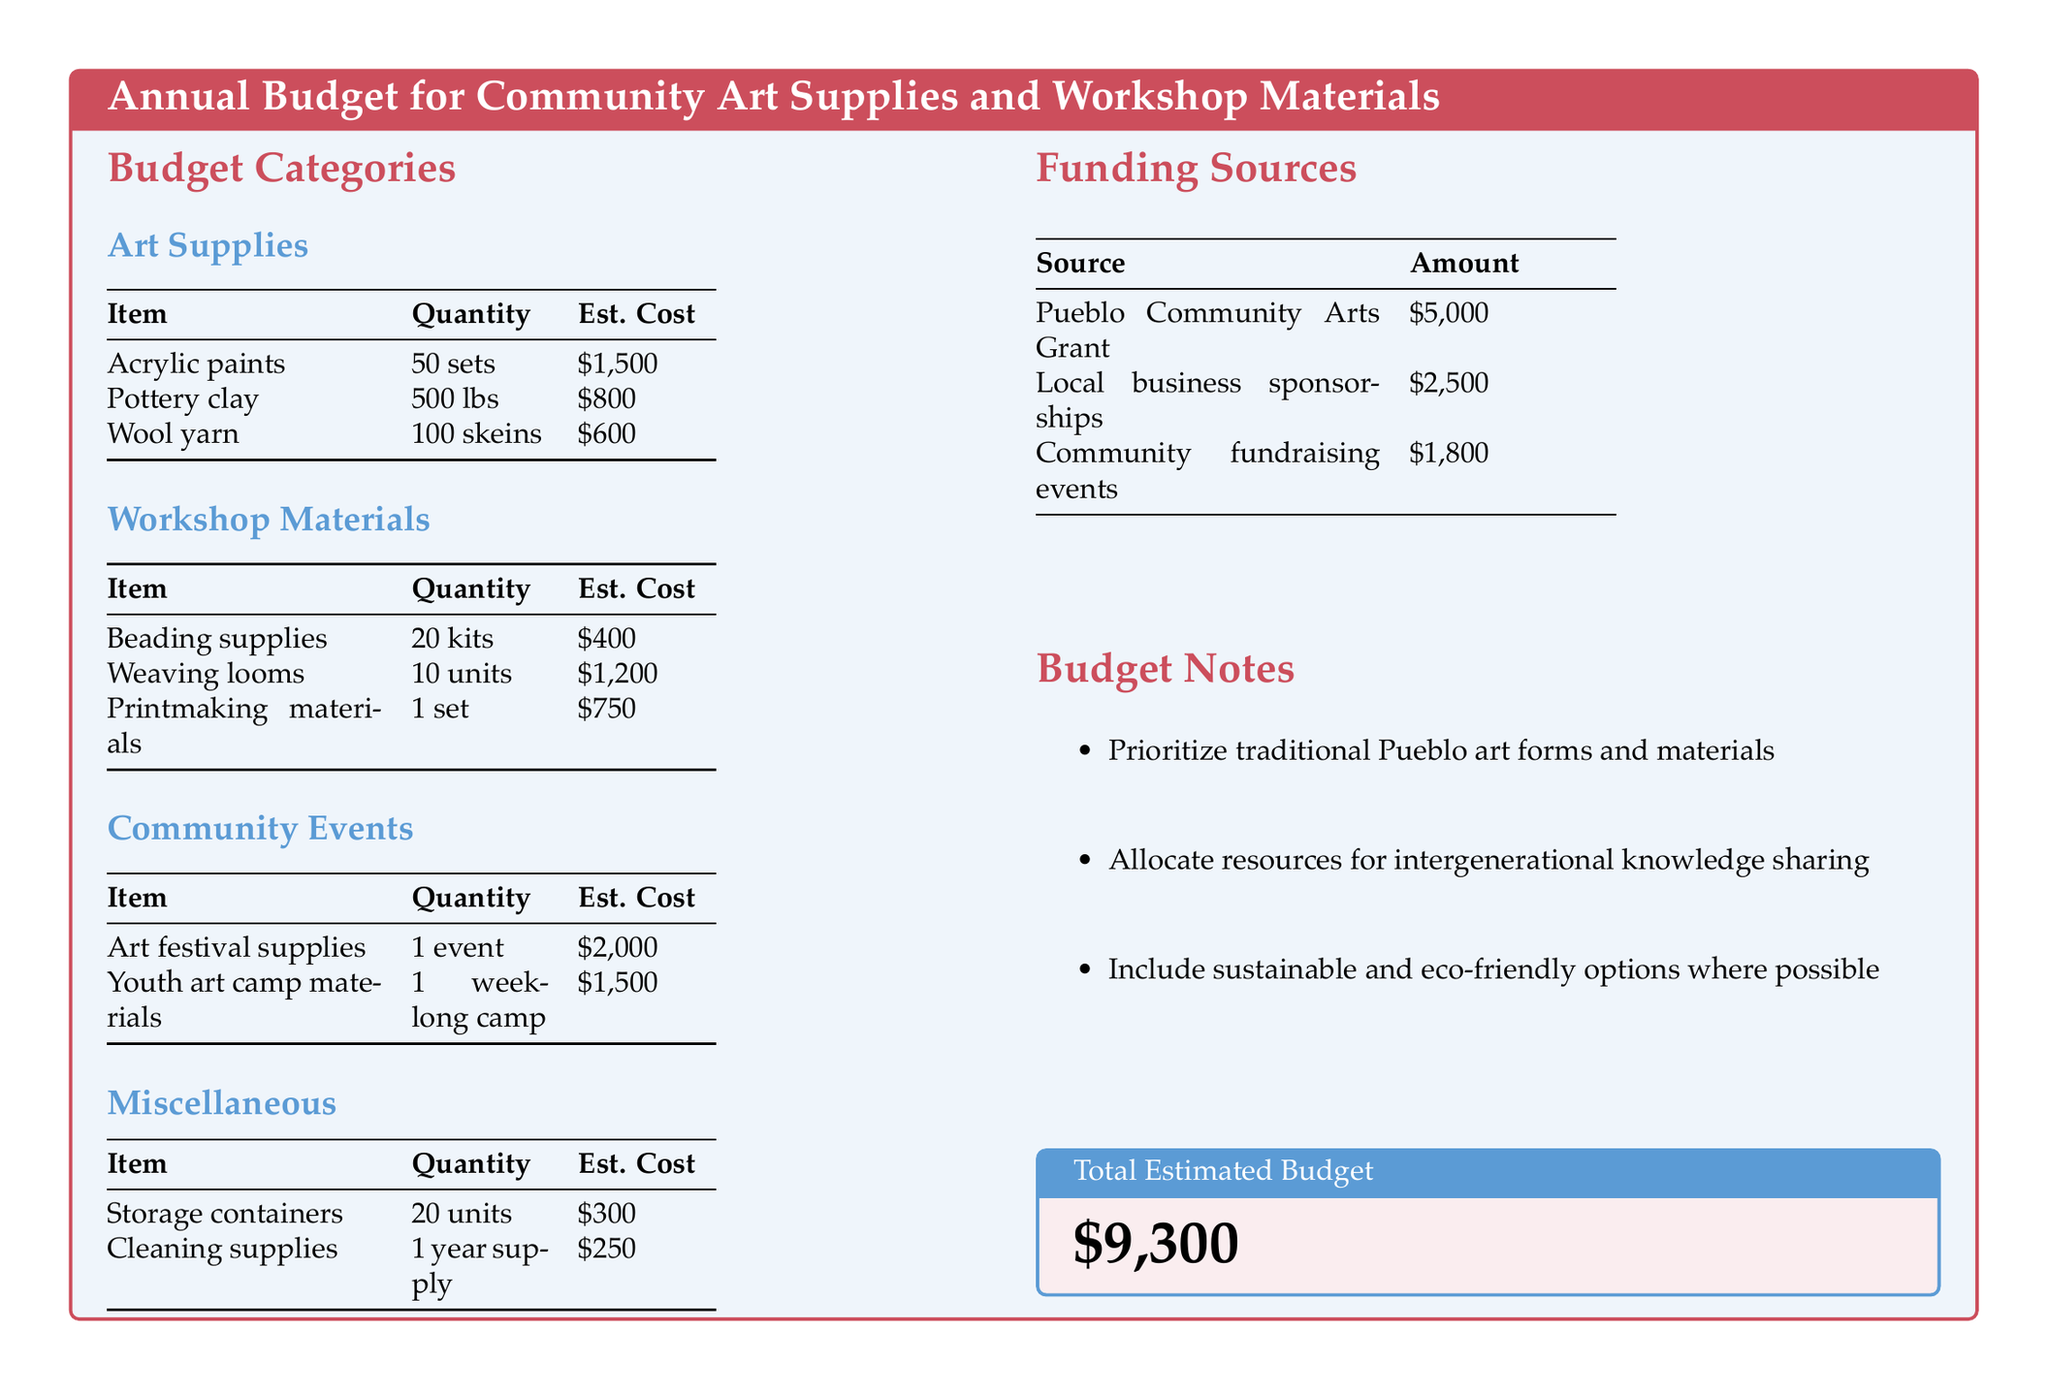What is the total estimated budget? The total estimated budget is provided in a separate box at the end of the document, which totals all the costs listed in the budget.
Answer: $9,300 How much is allocated for acrylic paints? The quantity and estimated cost of acrylic paints are listed under the Art Supplies category of the document.
Answer: $1,500 How many units of weaving looms are included in the budget? The number of weaving looms can be found in the Workshop Materials section of the budget, specifying the quantity allocated.
Answer: 10 units What is the source of the largest funding amount? The funding sources listed show various contributions, and the largest amount is highlighted as coming from a specific grant.
Answer: Pueblo Community Arts Grant What event has a budget of $2,000? The document outlines the cost of community events, and one event is specifically noted with this amount.
Answer: Art festival supplies How much is budgeted for cleaning supplies? The estimated cost for cleaning supplies is detailed in the Miscellaneous section of the budget, indicating the total expenditure for those supplies.
Answer: $250 What percentage of the total budget is allocated for Youth art camp materials? To find this percentage, the cost of youth art camp materials is divided by the total estimated budget and then multiplied by 100%. The specific figure is presented in the document.
Answer: 16.13% What type of materials are prioritized in the budget notes? The budget notes highlight a specific focus within the resource allocation that reflects the cultural identity and practice of the community's art.
Answer: Traditional Pueblo art forms How many kits of beading supplies are included? The number of kits for beading supplies can be found in the Workshop Materials section's table, revealing the planned quantity.
Answer: 20 kits What is the estimated cost for printmaking materials? The budget specifically lists the estimated cost for printmaking materials in the Workshop Materials section of the document.
Answer: $750 